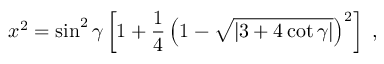<formula> <loc_0><loc_0><loc_500><loc_500>x ^ { 2 } = \sin ^ { 2 } \gamma \left [ 1 + \frac { 1 } { 4 } \left ( 1 - \sqrt { \left | 3 + 4 \, c o t \, \gamma \right | } \right ) ^ { 2 } \right ] \, ,</formula> 